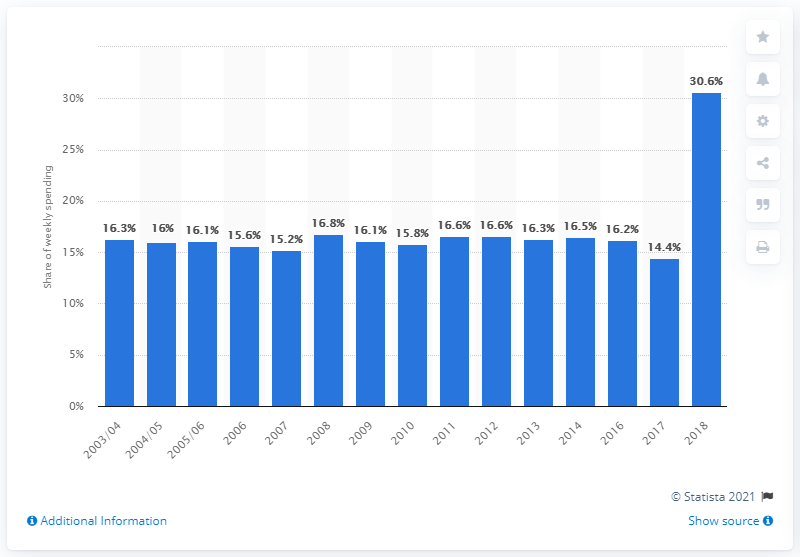List a handful of essential elements in this visual. In the year 2003/2004, the highest amount spent by low-income households was recorded. In 2018, food spending accounted for approximately 30.6% of household expenditures among the lowest income-earning households, according to the latest data available. 